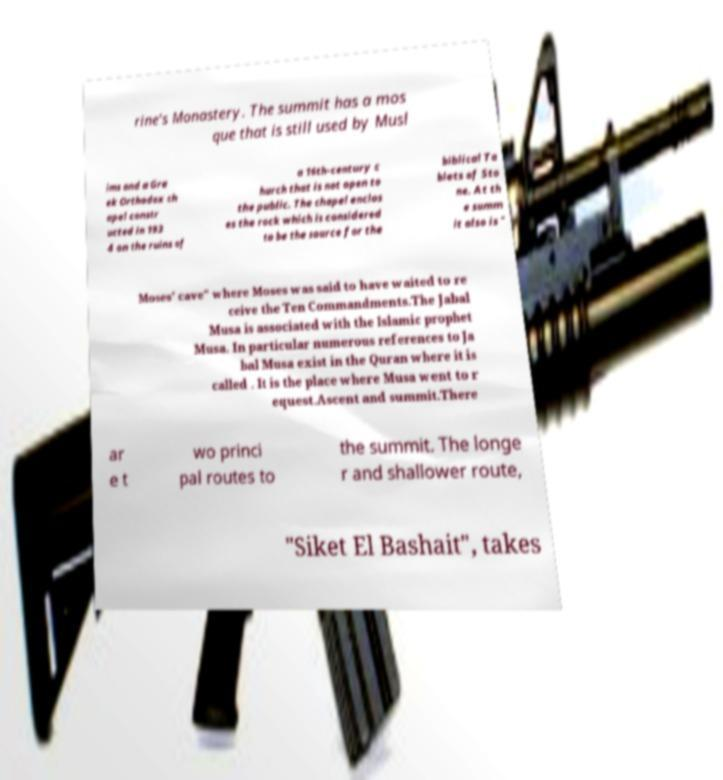Could you assist in decoding the text presented in this image and type it out clearly? rine's Monastery. The summit has a mos que that is still used by Musl ims and a Gre ek Orthodox ch apel constr ucted in 193 4 on the ruins of a 16th-century c hurch that is not open to the public. The chapel enclos es the rock which is considered to be the source for the biblical Ta blets of Sto ne. At th e summ it also is " Moses' cave" where Moses was said to have waited to re ceive the Ten Commandments.The Jabal Musa is associated with the Islamic prophet Musa. In particular numerous references to Ja bal Musa exist in the Quran where it is called . It is the place where Musa went to r equest.Ascent and summit.There ar e t wo princi pal routes to the summit. The longe r and shallower route, "Siket El Bashait", takes 